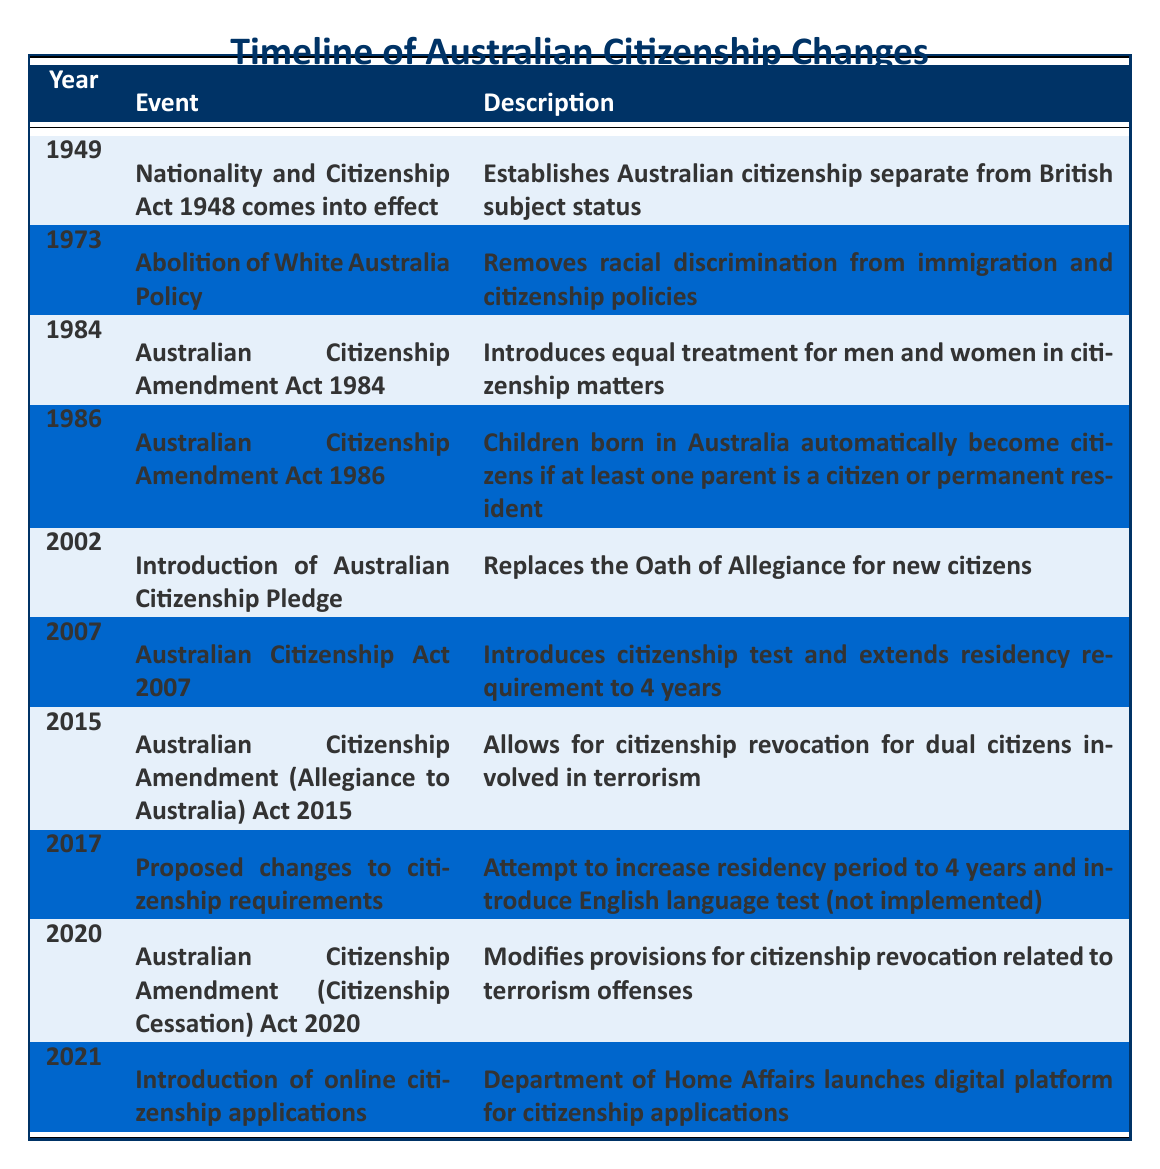What year did the Nationality and Citizenship Act come into effect? According to the table, the Nationality and Citizenship Act came into effect in 1949, as indicated in the first row.
Answer: 1949 How many significant events related to Australian citizenship occurred after 2000? By examining the table, we can count the events listed from the year 2002 to 2021, which gives us the following events: 2002, 2007, 2015, 2017, 2020, and 2021. That makes a total of 6 events.
Answer: 6 Did the Australian Citizenship Amendment Act of 1986 make any provisions regarding children? Yes, the table states that the Australian Citizenship Amendment Act of 1986 allows children born in Australia to automatically become citizens if at least one parent is a citizen or permanent resident.
Answer: Yes What was a key change introduced by the Australian Citizenship Act of 2007? The Australian Citizenship Act of 2007 is noted to have introduced a citizenship test and to have extended the residency requirement to 4 years, listed in the row for the year 2007.
Answer: Citizenship test and 4-year residency requirement Which two events occurred in the 2010s regarding Australian citizenship? The table shows that in 2015, the Australian Citizenship Amendment (Allegiance to Australia) Act was enacted, and in 2017, there was a proposed change to increase the residency period to 4 years and introduce an English language test. Therefore, the two events are from 2015 and 2017.
Answer: 2015 and 2017 What is the difference in years between the first and last events listed in the table? The first event is from 1949, and the last event is from 2021. To find the difference, we subtract 1949 from 2021, which gives us 72 years.
Answer: 72 years 